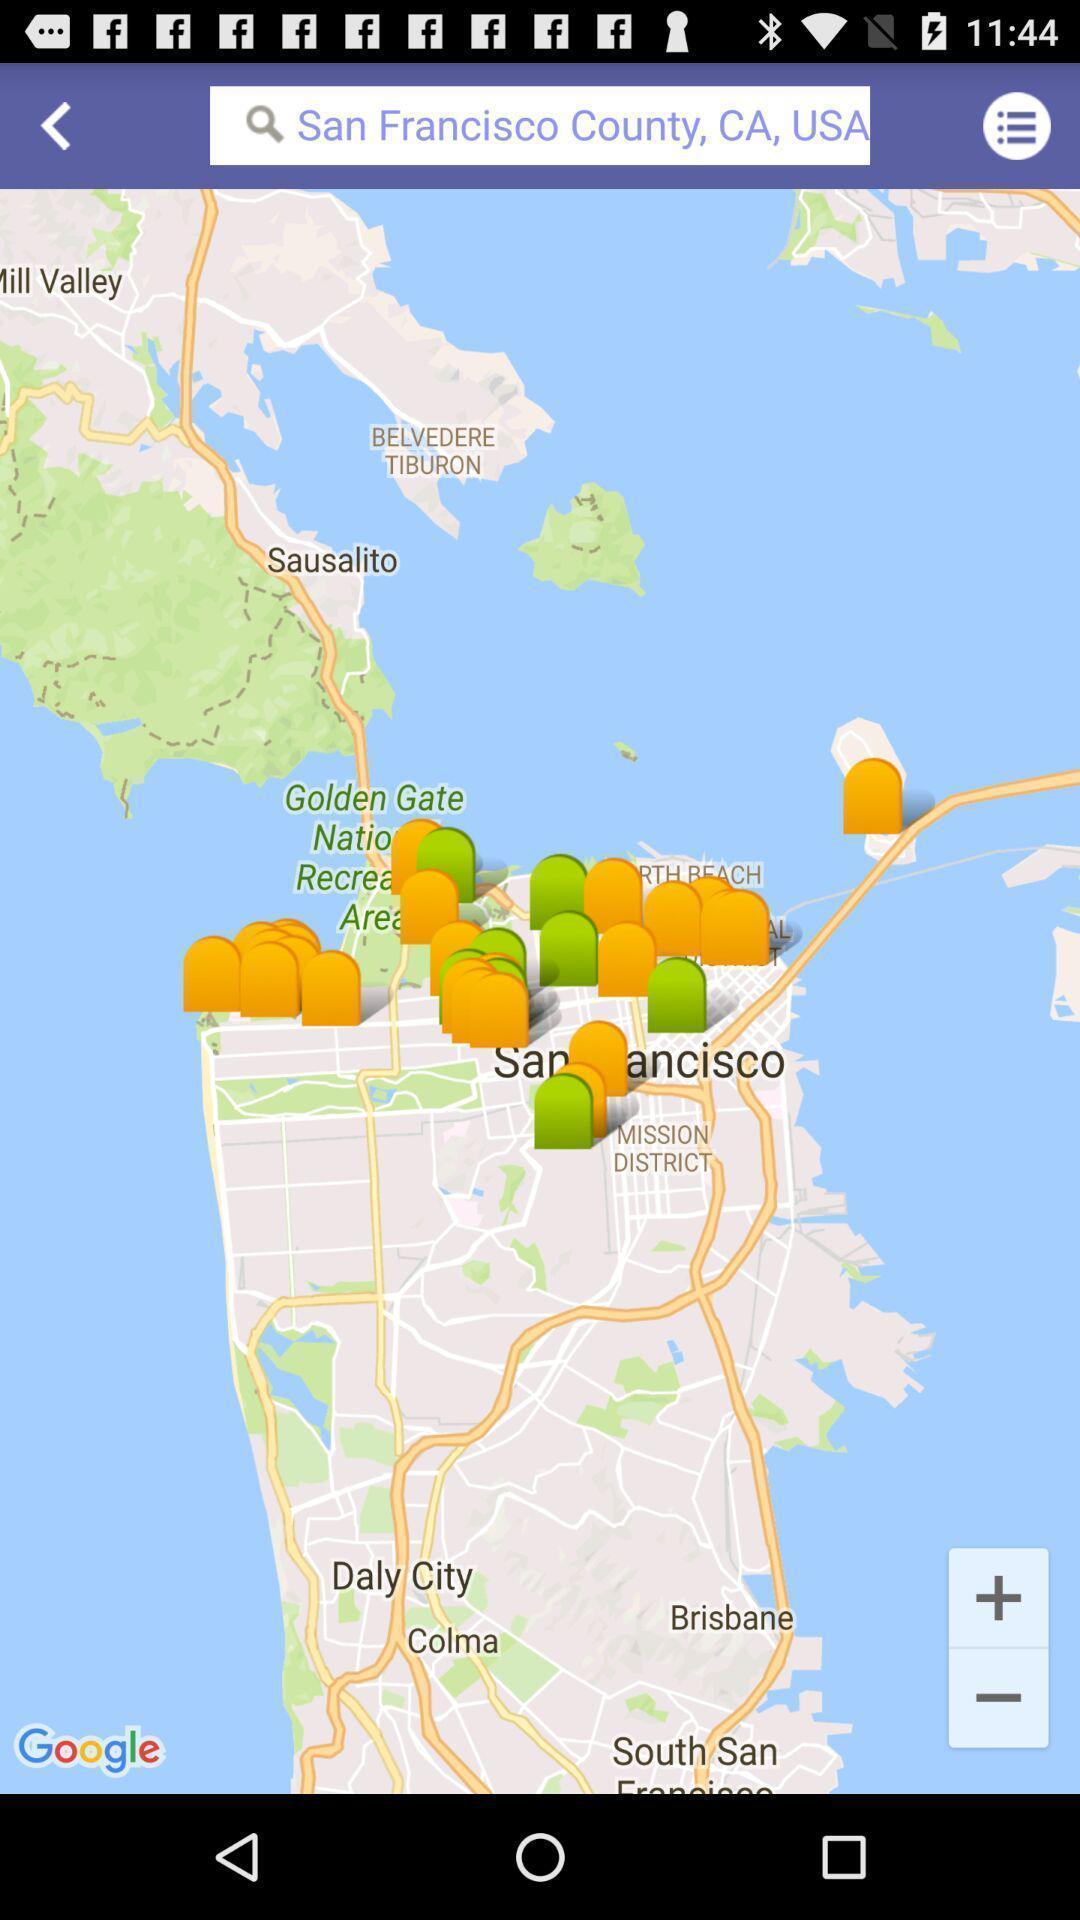Provide a description of this screenshot. Search bar to find memorials in location app. 